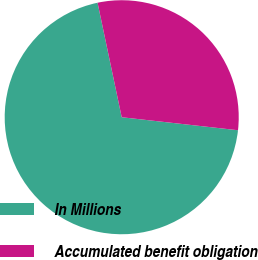<chart> <loc_0><loc_0><loc_500><loc_500><pie_chart><fcel>In Millions<fcel>Accumulated benefit obligation<nl><fcel>69.92%<fcel>30.08%<nl></chart> 